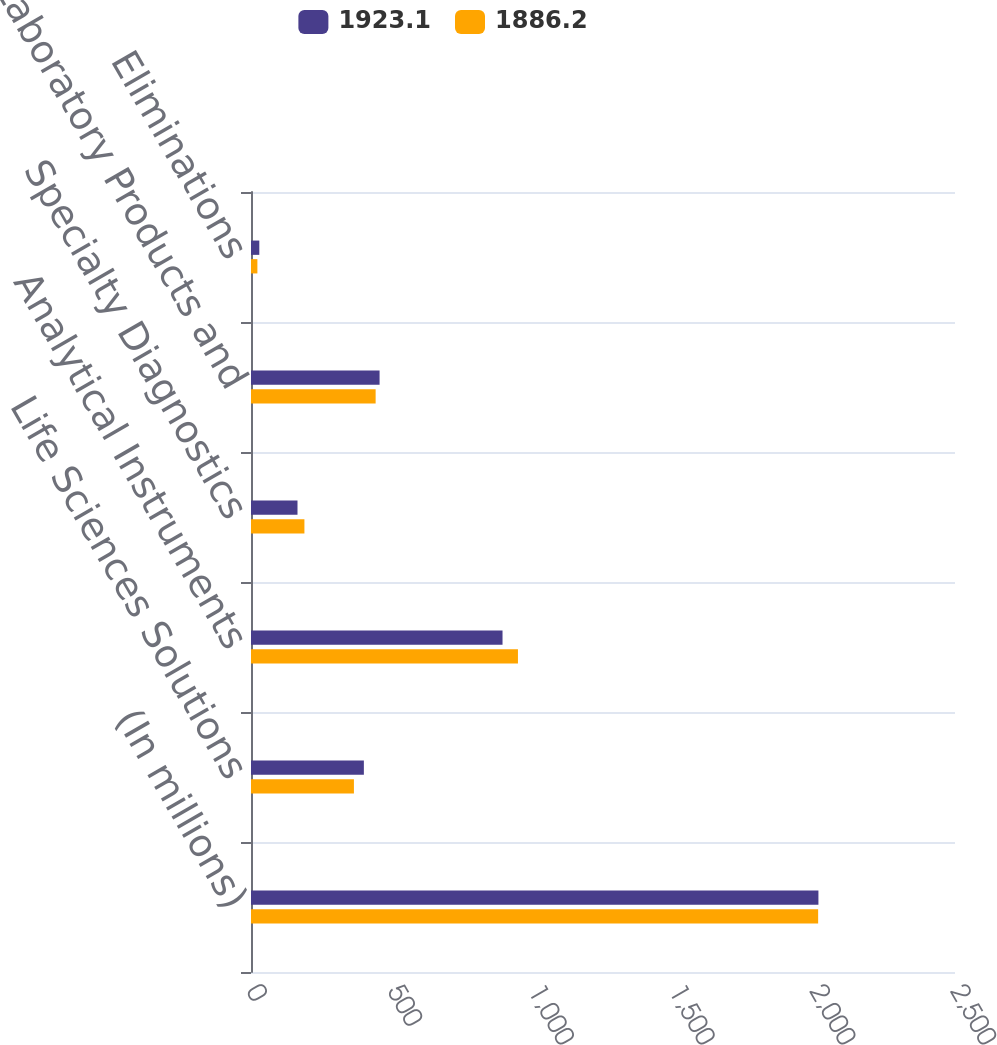<chart> <loc_0><loc_0><loc_500><loc_500><stacked_bar_chart><ecel><fcel>(In millions)<fcel>Life Sciences Solutions<fcel>Analytical Instruments<fcel>Specialty Diagnostics<fcel>Laboratory Products and<fcel>Eliminations<nl><fcel>1923.1<fcel>2015<fcel>400.8<fcel>893.2<fcel>165.1<fcel>456.6<fcel>29.5<nl><fcel>1886.2<fcel>2014<fcel>365.5<fcel>948<fcel>189.7<fcel>442.6<fcel>22.7<nl></chart> 